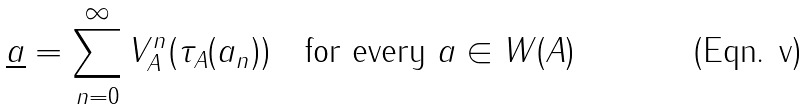Convert formula to latex. <formula><loc_0><loc_0><loc_500><loc_500>\underline { a } = \sum ^ { \infty } _ { n = 0 } V _ { A } ^ { n } ( \tau _ { A } ( a _ { n } ) ) \quad \text {for every $\underline{ }a\in W(A)$}</formula> 